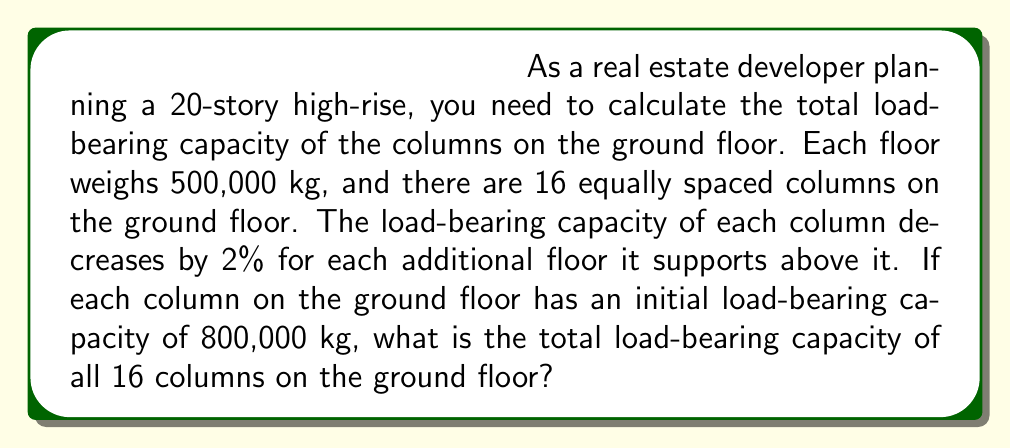Help me with this question. To solve this problem, we need to calculate the load-bearing capacity of each column and then sum them up. Let's break it down step by step:

1. Initial load-bearing capacity of each column: 800,000 kg

2. Decrease in capacity for each floor:
   $800,000 \times 0.02 = 16,000$ kg per floor

3. We need to calculate a series where each term represents the capacity of the column for each floor. This is an arithmetic sequence with:
   - First term $a_1 = 800,000$
   - Common difference $d = -16,000$
   - Number of terms $n = 20$ (for 20 floors)

4. The sum of an arithmetic sequence is given by:
   $$S_n = \frac{n}{2}(a_1 + a_n)$$
   where $a_n$ is the last term.

5. Calculate $a_n$:
   $a_n = a_1 + (n-1)d = 800,000 + (20-1)(-16,000) = 496,000$

6. Now we can calculate the sum:
   $$S_{20} = \frac{20}{2}(800,000 + 496,000) = 10 \times 1,296,000 = 12,960,000$$

7. This is the load-bearing capacity for one column. For all 16 columns:
   $12,960,000 \times 16 = 207,360,000$ kg

Therefore, the total load-bearing capacity of all 16 columns on the ground floor is 207,360,000 kg.
Answer: 207,360,000 kg 